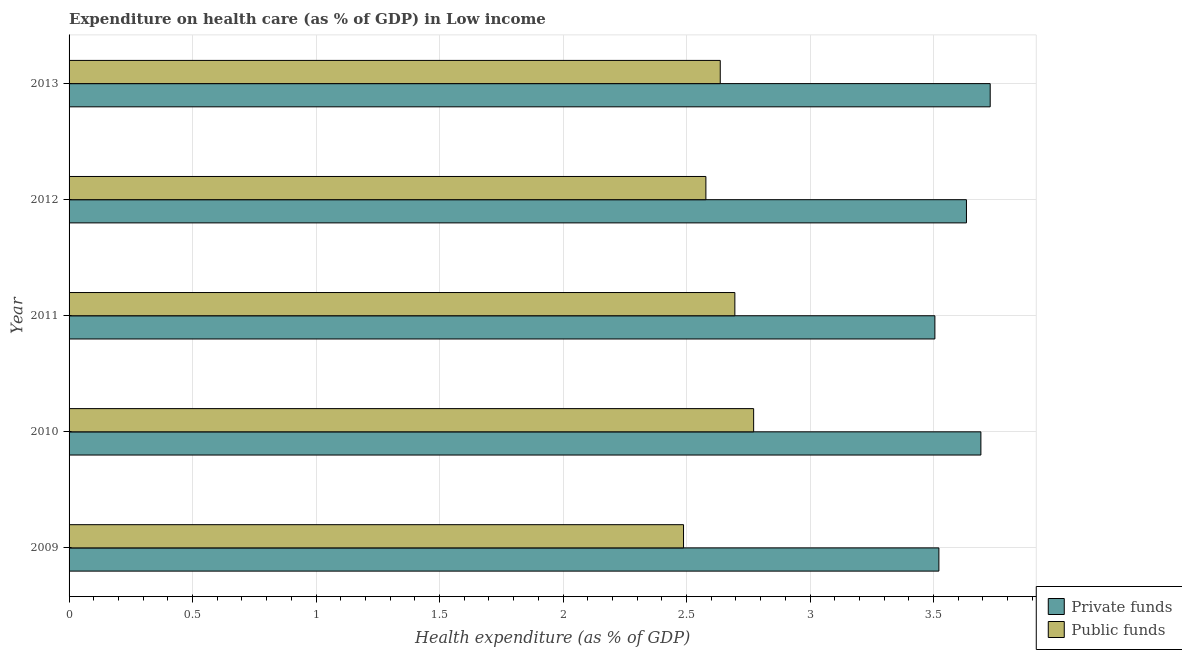Are the number of bars per tick equal to the number of legend labels?
Offer a very short reply. Yes. How many bars are there on the 1st tick from the top?
Keep it short and to the point. 2. In how many cases, is the number of bars for a given year not equal to the number of legend labels?
Make the answer very short. 0. What is the amount of private funds spent in healthcare in 2009?
Make the answer very short. 3.52. Across all years, what is the maximum amount of private funds spent in healthcare?
Your response must be concise. 3.73. Across all years, what is the minimum amount of private funds spent in healthcare?
Keep it short and to the point. 3.51. In which year was the amount of public funds spent in healthcare maximum?
Your answer should be very brief. 2010. In which year was the amount of private funds spent in healthcare minimum?
Your answer should be compact. 2011. What is the total amount of private funds spent in healthcare in the graph?
Keep it short and to the point. 18.08. What is the difference between the amount of public funds spent in healthcare in 2010 and that in 2012?
Your answer should be very brief. 0.19. What is the difference between the amount of private funds spent in healthcare in 2010 and the amount of public funds spent in healthcare in 2012?
Your answer should be compact. 1.11. What is the average amount of public funds spent in healthcare per year?
Ensure brevity in your answer.  2.63. In how many years, is the amount of public funds spent in healthcare greater than 3 %?
Your answer should be compact. 0. What is the ratio of the amount of private funds spent in healthcare in 2009 to that in 2010?
Your answer should be compact. 0.95. What is the difference between the highest and the second highest amount of public funds spent in healthcare?
Give a very brief answer. 0.08. What is the difference between the highest and the lowest amount of public funds spent in healthcare?
Offer a very short reply. 0.28. Is the sum of the amount of public funds spent in healthcare in 2009 and 2013 greater than the maximum amount of private funds spent in healthcare across all years?
Keep it short and to the point. Yes. What does the 2nd bar from the top in 2011 represents?
Give a very brief answer. Private funds. What does the 1st bar from the bottom in 2012 represents?
Make the answer very short. Private funds. Are all the bars in the graph horizontal?
Your answer should be very brief. Yes. How many years are there in the graph?
Ensure brevity in your answer.  5. Does the graph contain grids?
Your answer should be very brief. Yes. Where does the legend appear in the graph?
Ensure brevity in your answer.  Bottom right. How are the legend labels stacked?
Your answer should be compact. Vertical. What is the title of the graph?
Your response must be concise. Expenditure on health care (as % of GDP) in Low income. What is the label or title of the X-axis?
Your answer should be very brief. Health expenditure (as % of GDP). What is the Health expenditure (as % of GDP) in Private funds in 2009?
Offer a terse response. 3.52. What is the Health expenditure (as % of GDP) of Public funds in 2009?
Your response must be concise. 2.49. What is the Health expenditure (as % of GDP) in Private funds in 2010?
Offer a very short reply. 3.69. What is the Health expenditure (as % of GDP) in Public funds in 2010?
Give a very brief answer. 2.77. What is the Health expenditure (as % of GDP) in Private funds in 2011?
Your answer should be compact. 3.51. What is the Health expenditure (as % of GDP) in Public funds in 2011?
Give a very brief answer. 2.7. What is the Health expenditure (as % of GDP) of Private funds in 2012?
Provide a short and direct response. 3.63. What is the Health expenditure (as % of GDP) of Public funds in 2012?
Keep it short and to the point. 2.58. What is the Health expenditure (as % of GDP) of Private funds in 2013?
Your response must be concise. 3.73. What is the Health expenditure (as % of GDP) of Public funds in 2013?
Keep it short and to the point. 2.64. Across all years, what is the maximum Health expenditure (as % of GDP) of Private funds?
Your answer should be very brief. 3.73. Across all years, what is the maximum Health expenditure (as % of GDP) in Public funds?
Your answer should be very brief. 2.77. Across all years, what is the minimum Health expenditure (as % of GDP) of Private funds?
Provide a succinct answer. 3.51. Across all years, what is the minimum Health expenditure (as % of GDP) of Public funds?
Keep it short and to the point. 2.49. What is the total Health expenditure (as % of GDP) of Private funds in the graph?
Your answer should be compact. 18.08. What is the total Health expenditure (as % of GDP) of Public funds in the graph?
Your answer should be compact. 13.17. What is the difference between the Health expenditure (as % of GDP) in Private funds in 2009 and that in 2010?
Your answer should be compact. -0.17. What is the difference between the Health expenditure (as % of GDP) of Public funds in 2009 and that in 2010?
Offer a very short reply. -0.28. What is the difference between the Health expenditure (as % of GDP) of Private funds in 2009 and that in 2011?
Offer a terse response. 0.02. What is the difference between the Health expenditure (as % of GDP) of Public funds in 2009 and that in 2011?
Keep it short and to the point. -0.21. What is the difference between the Health expenditure (as % of GDP) in Private funds in 2009 and that in 2012?
Offer a very short reply. -0.11. What is the difference between the Health expenditure (as % of GDP) in Public funds in 2009 and that in 2012?
Your response must be concise. -0.09. What is the difference between the Health expenditure (as % of GDP) of Private funds in 2009 and that in 2013?
Offer a terse response. -0.21. What is the difference between the Health expenditure (as % of GDP) of Public funds in 2009 and that in 2013?
Provide a short and direct response. -0.15. What is the difference between the Health expenditure (as % of GDP) in Private funds in 2010 and that in 2011?
Keep it short and to the point. 0.19. What is the difference between the Health expenditure (as % of GDP) of Public funds in 2010 and that in 2011?
Provide a succinct answer. 0.08. What is the difference between the Health expenditure (as % of GDP) in Private funds in 2010 and that in 2012?
Your response must be concise. 0.06. What is the difference between the Health expenditure (as % of GDP) of Public funds in 2010 and that in 2012?
Make the answer very short. 0.19. What is the difference between the Health expenditure (as % of GDP) of Private funds in 2010 and that in 2013?
Your answer should be compact. -0.04. What is the difference between the Health expenditure (as % of GDP) of Public funds in 2010 and that in 2013?
Ensure brevity in your answer.  0.14. What is the difference between the Health expenditure (as % of GDP) in Private funds in 2011 and that in 2012?
Your answer should be compact. -0.13. What is the difference between the Health expenditure (as % of GDP) of Public funds in 2011 and that in 2012?
Give a very brief answer. 0.12. What is the difference between the Health expenditure (as % of GDP) of Private funds in 2011 and that in 2013?
Make the answer very short. -0.22. What is the difference between the Health expenditure (as % of GDP) of Public funds in 2011 and that in 2013?
Offer a terse response. 0.06. What is the difference between the Health expenditure (as % of GDP) in Private funds in 2012 and that in 2013?
Provide a succinct answer. -0.1. What is the difference between the Health expenditure (as % of GDP) of Public funds in 2012 and that in 2013?
Offer a terse response. -0.06. What is the difference between the Health expenditure (as % of GDP) of Private funds in 2009 and the Health expenditure (as % of GDP) of Public funds in 2010?
Your response must be concise. 0.75. What is the difference between the Health expenditure (as % of GDP) of Private funds in 2009 and the Health expenditure (as % of GDP) of Public funds in 2011?
Your answer should be very brief. 0.83. What is the difference between the Health expenditure (as % of GDP) of Private funds in 2009 and the Health expenditure (as % of GDP) of Public funds in 2012?
Your answer should be very brief. 0.94. What is the difference between the Health expenditure (as % of GDP) in Private funds in 2009 and the Health expenditure (as % of GDP) in Public funds in 2013?
Ensure brevity in your answer.  0.89. What is the difference between the Health expenditure (as % of GDP) in Private funds in 2010 and the Health expenditure (as % of GDP) in Public funds in 2012?
Keep it short and to the point. 1.11. What is the difference between the Health expenditure (as % of GDP) in Private funds in 2010 and the Health expenditure (as % of GDP) in Public funds in 2013?
Keep it short and to the point. 1.06. What is the difference between the Health expenditure (as % of GDP) in Private funds in 2011 and the Health expenditure (as % of GDP) in Public funds in 2012?
Offer a terse response. 0.93. What is the difference between the Health expenditure (as % of GDP) in Private funds in 2011 and the Health expenditure (as % of GDP) in Public funds in 2013?
Keep it short and to the point. 0.87. What is the difference between the Health expenditure (as % of GDP) in Private funds in 2012 and the Health expenditure (as % of GDP) in Public funds in 2013?
Offer a very short reply. 1. What is the average Health expenditure (as % of GDP) of Private funds per year?
Ensure brevity in your answer.  3.62. What is the average Health expenditure (as % of GDP) of Public funds per year?
Give a very brief answer. 2.63. In the year 2009, what is the difference between the Health expenditure (as % of GDP) in Private funds and Health expenditure (as % of GDP) in Public funds?
Offer a very short reply. 1.03. In the year 2010, what is the difference between the Health expenditure (as % of GDP) of Private funds and Health expenditure (as % of GDP) of Public funds?
Your response must be concise. 0.92. In the year 2011, what is the difference between the Health expenditure (as % of GDP) of Private funds and Health expenditure (as % of GDP) of Public funds?
Provide a succinct answer. 0.81. In the year 2012, what is the difference between the Health expenditure (as % of GDP) in Private funds and Health expenditure (as % of GDP) in Public funds?
Your response must be concise. 1.05. In the year 2013, what is the difference between the Health expenditure (as % of GDP) in Private funds and Health expenditure (as % of GDP) in Public funds?
Offer a very short reply. 1.09. What is the ratio of the Health expenditure (as % of GDP) in Private funds in 2009 to that in 2010?
Your response must be concise. 0.95. What is the ratio of the Health expenditure (as % of GDP) of Public funds in 2009 to that in 2010?
Offer a very short reply. 0.9. What is the ratio of the Health expenditure (as % of GDP) of Private funds in 2009 to that in 2011?
Provide a short and direct response. 1. What is the ratio of the Health expenditure (as % of GDP) of Public funds in 2009 to that in 2011?
Keep it short and to the point. 0.92. What is the ratio of the Health expenditure (as % of GDP) of Private funds in 2009 to that in 2012?
Provide a short and direct response. 0.97. What is the ratio of the Health expenditure (as % of GDP) in Public funds in 2009 to that in 2012?
Your answer should be very brief. 0.96. What is the ratio of the Health expenditure (as % of GDP) of Private funds in 2009 to that in 2013?
Offer a terse response. 0.94. What is the ratio of the Health expenditure (as % of GDP) of Public funds in 2009 to that in 2013?
Ensure brevity in your answer.  0.94. What is the ratio of the Health expenditure (as % of GDP) in Private funds in 2010 to that in 2011?
Make the answer very short. 1.05. What is the ratio of the Health expenditure (as % of GDP) of Public funds in 2010 to that in 2011?
Your response must be concise. 1.03. What is the ratio of the Health expenditure (as % of GDP) in Private funds in 2010 to that in 2012?
Your answer should be very brief. 1.02. What is the ratio of the Health expenditure (as % of GDP) in Public funds in 2010 to that in 2012?
Offer a very short reply. 1.07. What is the ratio of the Health expenditure (as % of GDP) in Public funds in 2010 to that in 2013?
Your answer should be compact. 1.05. What is the ratio of the Health expenditure (as % of GDP) of Private funds in 2011 to that in 2012?
Your answer should be compact. 0.96. What is the ratio of the Health expenditure (as % of GDP) of Public funds in 2011 to that in 2012?
Keep it short and to the point. 1.05. What is the ratio of the Health expenditure (as % of GDP) in Private funds in 2011 to that in 2013?
Offer a very short reply. 0.94. What is the ratio of the Health expenditure (as % of GDP) in Public funds in 2011 to that in 2013?
Provide a succinct answer. 1.02. What is the ratio of the Health expenditure (as % of GDP) in Private funds in 2012 to that in 2013?
Give a very brief answer. 0.97. What is the ratio of the Health expenditure (as % of GDP) of Public funds in 2012 to that in 2013?
Offer a very short reply. 0.98. What is the difference between the highest and the second highest Health expenditure (as % of GDP) of Private funds?
Offer a very short reply. 0.04. What is the difference between the highest and the second highest Health expenditure (as % of GDP) of Public funds?
Give a very brief answer. 0.08. What is the difference between the highest and the lowest Health expenditure (as % of GDP) in Private funds?
Provide a succinct answer. 0.22. What is the difference between the highest and the lowest Health expenditure (as % of GDP) of Public funds?
Give a very brief answer. 0.28. 